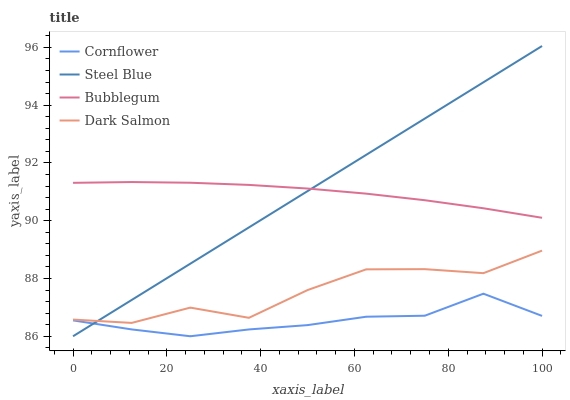Does Cornflower have the minimum area under the curve?
Answer yes or no. Yes. Does Steel Blue have the maximum area under the curve?
Answer yes or no. Yes. Does Bubblegum have the minimum area under the curve?
Answer yes or no. No. Does Bubblegum have the maximum area under the curve?
Answer yes or no. No. Is Steel Blue the smoothest?
Answer yes or no. Yes. Is Dark Salmon the roughest?
Answer yes or no. Yes. Is Bubblegum the smoothest?
Answer yes or no. No. Is Bubblegum the roughest?
Answer yes or no. No. Does Cornflower have the lowest value?
Answer yes or no. Yes. Does Bubblegum have the lowest value?
Answer yes or no. No. Does Steel Blue have the highest value?
Answer yes or no. Yes. Does Bubblegum have the highest value?
Answer yes or no. No. Is Dark Salmon less than Bubblegum?
Answer yes or no. Yes. Is Bubblegum greater than Dark Salmon?
Answer yes or no. Yes. Does Cornflower intersect Steel Blue?
Answer yes or no. Yes. Is Cornflower less than Steel Blue?
Answer yes or no. No. Is Cornflower greater than Steel Blue?
Answer yes or no. No. Does Dark Salmon intersect Bubblegum?
Answer yes or no. No. 